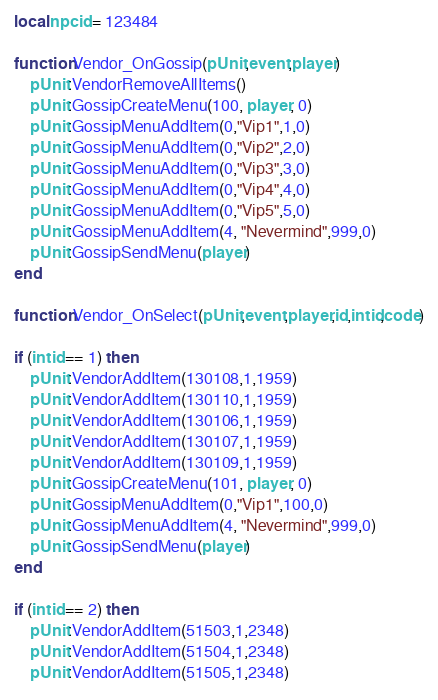Convert code to text. <code><loc_0><loc_0><loc_500><loc_500><_Lua_>local npcid = 123484

function Vendor_OnGossip(pUnit,event,player)
	pUnit:VendorRemoveAllItems()
	pUnit:GossipCreateMenu(100, player, 0)
	pUnit:GossipMenuAddItem(0,"Vip1",1,0)
	pUnit:GossipMenuAddItem(0,"Vip2",2,0)
	pUnit:GossipMenuAddItem(0,"Vip3",3,0)
	pUnit:GossipMenuAddItem(0,"Vip4",4,0)
	pUnit:GossipMenuAddItem(0,"Vip5",5,0)
	pUnit:GossipMenuAddItem(4, "Nevermind",999,0)
	pUnit:GossipSendMenu(player)
end

function Vendor_OnSelect(pUnit,event,player,id,intid,code)

if (intid == 1) then
	pUnit:VendorAddItem(130108,1,1959)
	pUnit:VendorAddItem(130110,1,1959)
	pUnit:VendorAddItem(130106,1,1959)
	pUnit:VendorAddItem(130107,1,1959)
	pUnit:VendorAddItem(130109,1,1959)
	pUnit:GossipCreateMenu(101, player, 0)
	pUnit:GossipMenuAddItem(0,"Vip1",100,0)
	pUnit:GossipMenuAddItem(4, "Nevermind",999,0)
	pUnit:GossipSendMenu(player)
end

if (intid == 2) then
	pUnit:VendorAddItem(51503,1,2348)
	pUnit:VendorAddItem(51504,1,2348)
	pUnit:VendorAddItem(51505,1,2348)</code> 